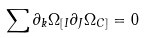<formula> <loc_0><loc_0><loc_500><loc_500>\sum \partial _ { k } \Omega _ { [ I } \partial _ { J } \Omega _ { C ] } = 0</formula> 